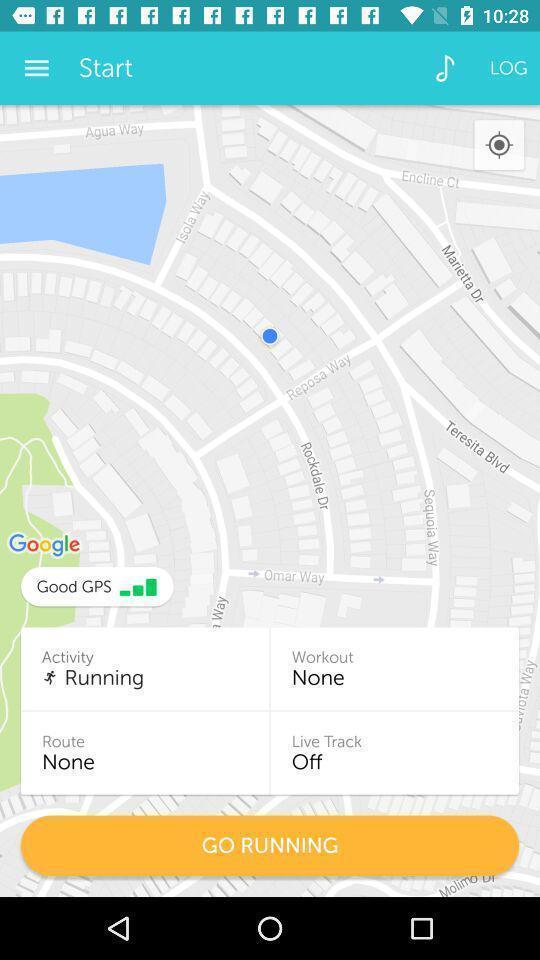Describe this image in words. Page displaying with maps and tracker in fitness application. 